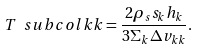<formula> <loc_0><loc_0><loc_500><loc_500>T \ s u b { c o l } { k k } = \frac { 2 \rho _ { s } s _ { k } h _ { k } } { 3 \Sigma _ { k } \Delta v _ { k k } } . \label H { e q \colon T c o l }</formula> 